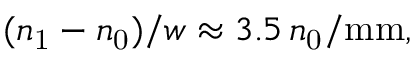Convert formula to latex. <formula><loc_0><loc_0><loc_500><loc_500>( n _ { 1 } - n _ { 0 } ) / w \approx 3 . 5 \, n _ { 0 } / m m ,</formula> 